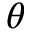<formula> <loc_0><loc_0><loc_500><loc_500>\theta</formula> 